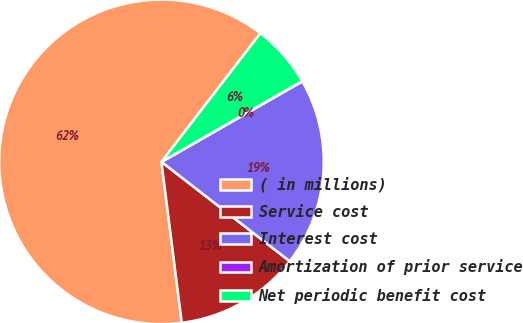Convert chart to OTSL. <chart><loc_0><loc_0><loc_500><loc_500><pie_chart><fcel>( in millions)<fcel>Service cost<fcel>Interest cost<fcel>Amortization of prior service<fcel>Net periodic benefit cost<nl><fcel>62.43%<fcel>12.51%<fcel>18.75%<fcel>0.03%<fcel>6.27%<nl></chart> 